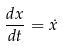<formula> <loc_0><loc_0><loc_500><loc_500>\frac { d x } { d t } = \dot { x }</formula> 